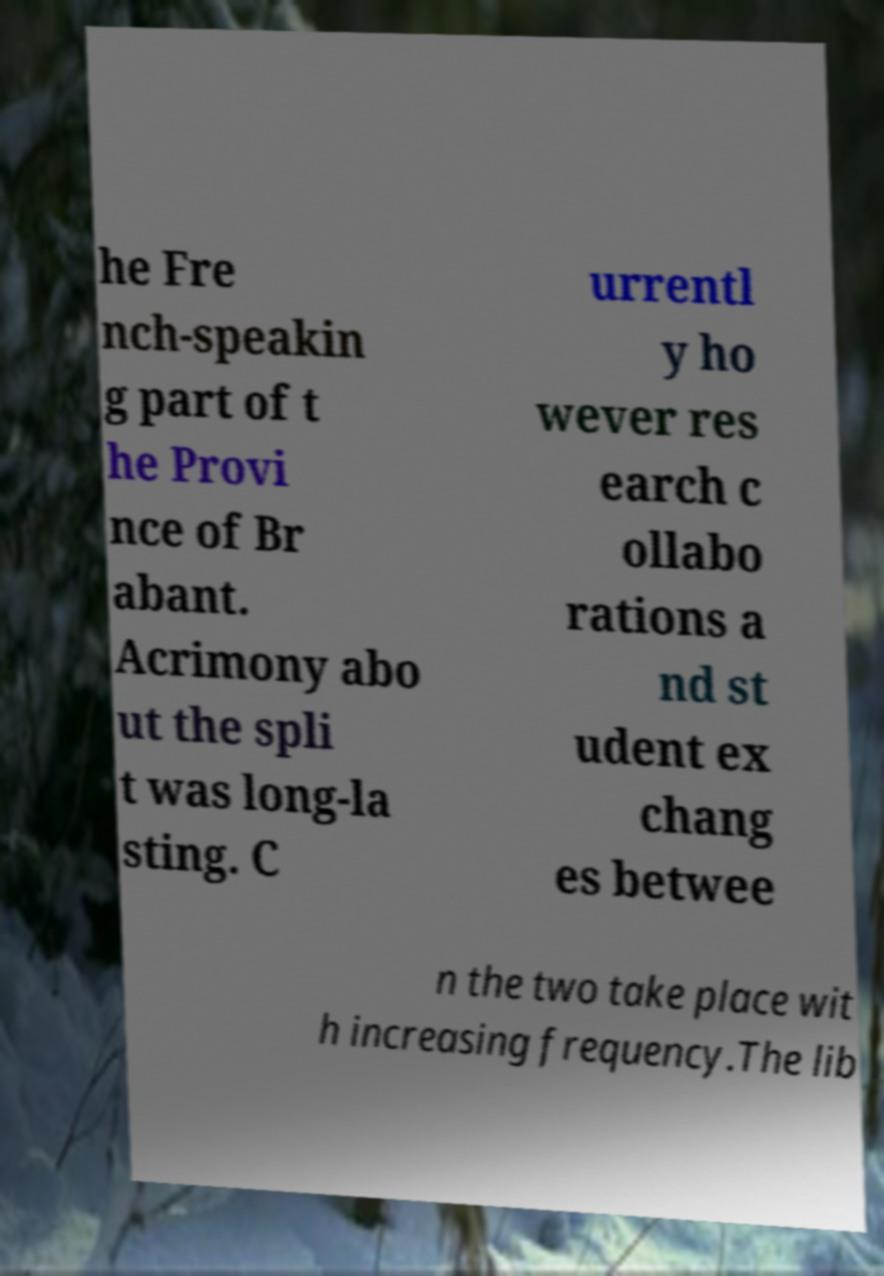There's text embedded in this image that I need extracted. Can you transcribe it verbatim? he Fre nch-speakin g part of t he Provi nce of Br abant. Acrimony abo ut the spli t was long-la sting. C urrentl y ho wever res earch c ollabo rations a nd st udent ex chang es betwee n the two take place wit h increasing frequency.The lib 